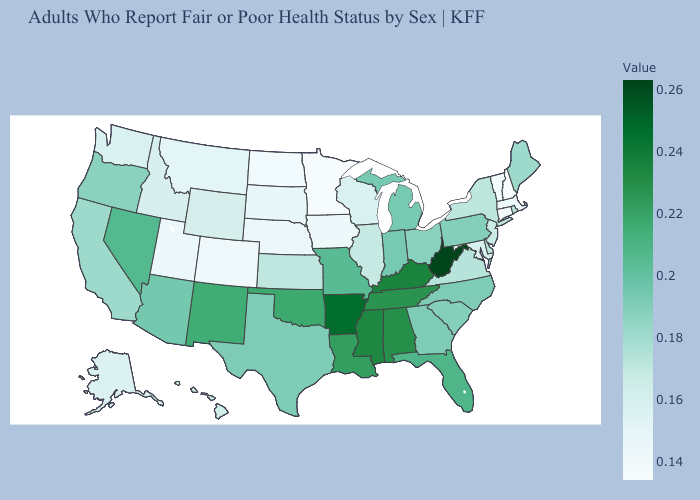Does New Hampshire have the lowest value in the Northeast?
Keep it brief. Yes. Does Pennsylvania have a higher value than Rhode Island?
Answer briefly. Yes. Which states hav the highest value in the MidWest?
Short answer required. Missouri. Among the states that border Alabama , which have the lowest value?
Keep it brief. Georgia. Does West Virginia have the highest value in the USA?
Give a very brief answer. Yes. Does New Mexico have the highest value in the West?
Answer briefly. Yes. Which states have the lowest value in the USA?
Quick response, please. New Hampshire. 